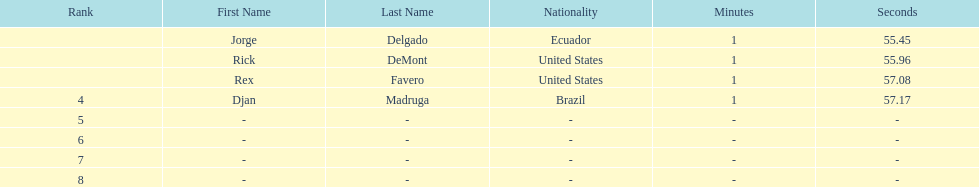Who was the last finisher from the us? Rex Favero. 